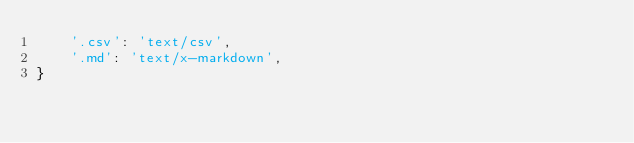Convert code to text. <code><loc_0><loc_0><loc_500><loc_500><_Python_>    '.csv': 'text/csv',
    '.md': 'text/x-markdown',
}
</code> 